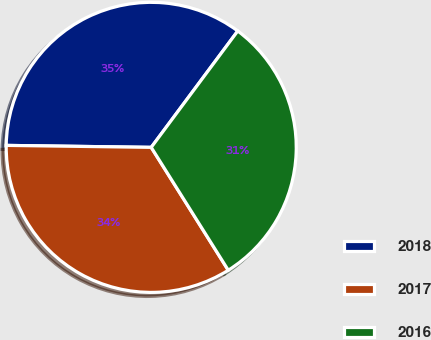Convert chart to OTSL. <chart><loc_0><loc_0><loc_500><loc_500><pie_chart><fcel>2018<fcel>2017<fcel>2016<nl><fcel>34.96%<fcel>34.13%<fcel>30.91%<nl></chart> 